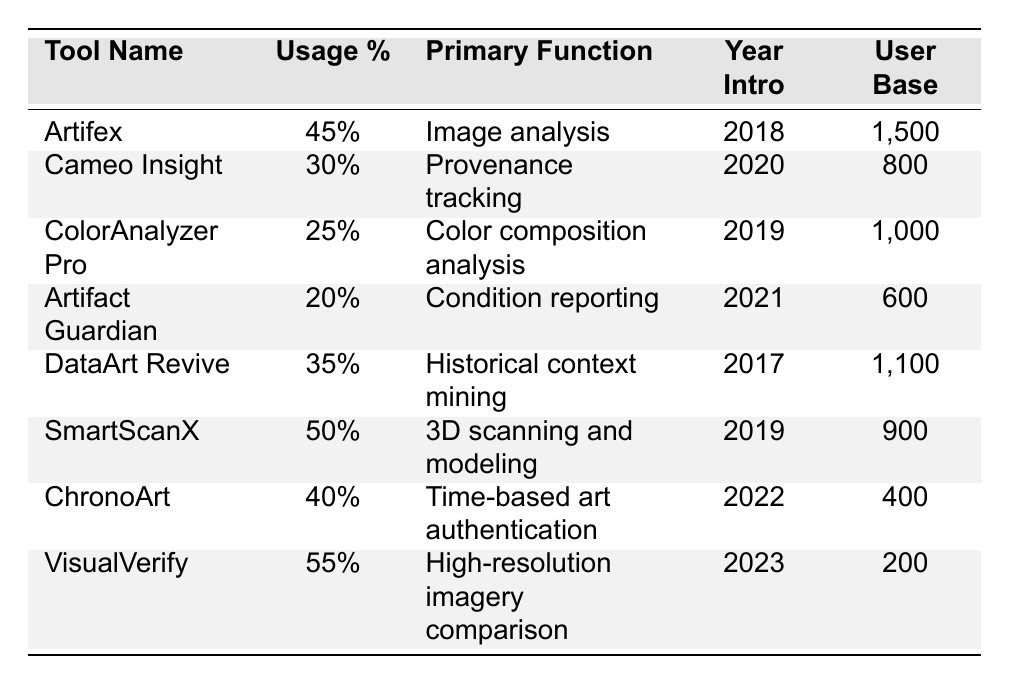What is the primary function of SmartScanX? SmartScanX's primary function is explicitly listed in the table under "Primary Function," which states it is for "3D scanning and modeling."
Answer: 3D scanning and modeling Which tool has the largest user base? By comparing the values in the "User Base" column, Artifex has the largest user base with 1500 users.
Answer: Artifex What is the average usage percentage of tools introduced in 2020? The tools introduced in 2020 are Cameo Insight and ChronoArt. Their usage percentages are 30% and 40%, respectively. (30 + 40) / 2 = 35.
Answer: 35% Is ColorAnalyzer Pro used by more or less than 1000 users? The user base for ColorAnalyzer Pro is explicitly stated as 1000, indicating it is equal to 1000 users, not more or less.
Answer: Equal Which tool was introduced first, Artifex or DataArt Revive? Checking the "Year Intro" column, DataArt Revive was introduced in 2017 and Artifex in 2018. Therefore, DataArt Revive was introduced first.
Answer: DataArt Revive Calculate the total user base for all tools introduced after 2019. The tools introduced after 2019 are Cameo Insight, Artifact Guardian, ChronoArt, and VisualVerify. Their user bases are 800, 600, 400, and 200, respectively. (800 + 600 + 400 + 200) = 2000.
Answer: 2000 Is the percentage usage of Artifact Guardian higher than the average usage percentage of all tools listed? The total usage percentages are 45, 30, 25, 20, 35, 50, 40, and 55 (sum = 300). There are 8 tools, so the average is 300 / 8 = 37.5. Artifact Guardian's usage percentage is 20, which is less than 37.5.
Answer: No What is the difference between the usage percentage of VisualVerify and SmartScanX? VisualVerify has a usage percentage of 55% and SmartScanX has 50%. The difference is calculated as 55 - 50 = 5.
Answer: 5% Which two tools have the same primary function? The table does not show any duplicate primary functions among the tools listed, indicating that each tool serves a distinct function.
Answer: None What is the percentage increase of usage from DataArt Revive to SmartScanX? DataArt Revive's usage percentage is 35% and SmartScanX's is 50%. The percentage increase is calculated as ((50 - 35) / 35) * 100 = 42.86%.
Answer: 42.86% 